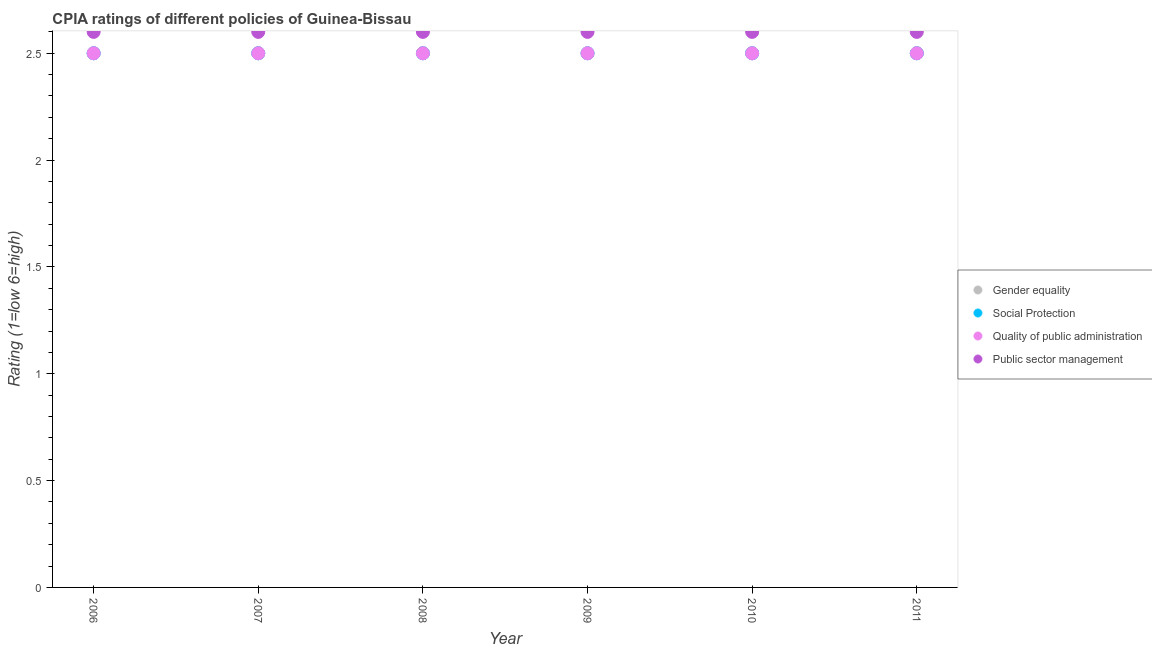Is the number of dotlines equal to the number of legend labels?
Make the answer very short. Yes. Across all years, what is the minimum cpia rating of public sector management?
Keep it short and to the point. 2.6. In which year was the cpia rating of gender equality maximum?
Your answer should be compact. 2006. What is the total cpia rating of social protection in the graph?
Provide a succinct answer. 15. What is the difference between the cpia rating of gender equality in 2011 and the cpia rating of public sector management in 2010?
Offer a very short reply. -0.1. In the year 2010, what is the difference between the cpia rating of quality of public administration and cpia rating of public sector management?
Offer a terse response. -0.1. In how many years, is the cpia rating of quality of public administration greater than 1.4?
Make the answer very short. 6. What is the ratio of the cpia rating of public sector management in 2006 to that in 2008?
Give a very brief answer. 1. Is the cpia rating of quality of public administration in 2009 less than that in 2011?
Your answer should be compact. No. Is the difference between the cpia rating of quality of public administration in 2007 and 2010 greater than the difference between the cpia rating of gender equality in 2007 and 2010?
Offer a very short reply. No. What is the difference between the highest and the lowest cpia rating of social protection?
Provide a short and direct response. 0. In how many years, is the cpia rating of public sector management greater than the average cpia rating of public sector management taken over all years?
Provide a succinct answer. 0. Is it the case that in every year, the sum of the cpia rating of public sector management and cpia rating of gender equality is greater than the sum of cpia rating of quality of public administration and cpia rating of social protection?
Provide a succinct answer. Yes. Is it the case that in every year, the sum of the cpia rating of gender equality and cpia rating of social protection is greater than the cpia rating of quality of public administration?
Keep it short and to the point. Yes. Is the cpia rating of social protection strictly less than the cpia rating of quality of public administration over the years?
Give a very brief answer. No. What is the difference between two consecutive major ticks on the Y-axis?
Make the answer very short. 0.5. Does the graph contain any zero values?
Ensure brevity in your answer.  No. Does the graph contain grids?
Provide a succinct answer. No. How many legend labels are there?
Make the answer very short. 4. What is the title of the graph?
Keep it short and to the point. CPIA ratings of different policies of Guinea-Bissau. Does "Minerals" appear as one of the legend labels in the graph?
Provide a short and direct response. No. What is the label or title of the X-axis?
Your response must be concise. Year. What is the label or title of the Y-axis?
Ensure brevity in your answer.  Rating (1=low 6=high). What is the Rating (1=low 6=high) in Social Protection in 2006?
Your answer should be very brief. 2.5. What is the Rating (1=low 6=high) in Public sector management in 2006?
Your answer should be compact. 2.6. What is the Rating (1=low 6=high) of Quality of public administration in 2007?
Give a very brief answer. 2.5. What is the Rating (1=low 6=high) in Gender equality in 2008?
Keep it short and to the point. 2.5. What is the Rating (1=low 6=high) in Social Protection in 2008?
Your response must be concise. 2.5. What is the Rating (1=low 6=high) in Quality of public administration in 2008?
Make the answer very short. 2.5. What is the Rating (1=low 6=high) in Gender equality in 2009?
Keep it short and to the point. 2.5. What is the Rating (1=low 6=high) in Social Protection in 2009?
Offer a terse response. 2.5. What is the Rating (1=low 6=high) in Gender equality in 2010?
Make the answer very short. 2.5. What is the Rating (1=low 6=high) of Social Protection in 2010?
Keep it short and to the point. 2.5. What is the Rating (1=low 6=high) in Public sector management in 2010?
Offer a very short reply. 2.6. What is the Rating (1=low 6=high) in Gender equality in 2011?
Your response must be concise. 2.5. What is the Rating (1=low 6=high) in Social Protection in 2011?
Offer a very short reply. 2.5. Across all years, what is the maximum Rating (1=low 6=high) of Gender equality?
Make the answer very short. 2.5. Across all years, what is the maximum Rating (1=low 6=high) of Quality of public administration?
Offer a very short reply. 2.5. Across all years, what is the minimum Rating (1=low 6=high) in Gender equality?
Offer a terse response. 2.5. Across all years, what is the minimum Rating (1=low 6=high) in Public sector management?
Your answer should be very brief. 2.6. What is the total Rating (1=low 6=high) of Gender equality in the graph?
Ensure brevity in your answer.  15. What is the total Rating (1=low 6=high) in Quality of public administration in the graph?
Offer a very short reply. 15. What is the difference between the Rating (1=low 6=high) of Quality of public administration in 2006 and that in 2007?
Your answer should be very brief. 0. What is the difference between the Rating (1=low 6=high) of Quality of public administration in 2006 and that in 2008?
Make the answer very short. 0. What is the difference between the Rating (1=low 6=high) in Public sector management in 2006 and that in 2008?
Offer a very short reply. 0. What is the difference between the Rating (1=low 6=high) in Social Protection in 2006 and that in 2009?
Ensure brevity in your answer.  0. What is the difference between the Rating (1=low 6=high) in Public sector management in 2006 and that in 2009?
Provide a short and direct response. 0. What is the difference between the Rating (1=low 6=high) in Social Protection in 2006 and that in 2010?
Provide a short and direct response. 0. What is the difference between the Rating (1=low 6=high) in Quality of public administration in 2006 and that in 2010?
Provide a succinct answer. 0. What is the difference between the Rating (1=low 6=high) of Public sector management in 2006 and that in 2010?
Your answer should be very brief. 0. What is the difference between the Rating (1=low 6=high) in Gender equality in 2006 and that in 2011?
Make the answer very short. 0. What is the difference between the Rating (1=low 6=high) of Social Protection in 2006 and that in 2011?
Keep it short and to the point. 0. What is the difference between the Rating (1=low 6=high) of Quality of public administration in 2006 and that in 2011?
Your answer should be very brief. 0. What is the difference between the Rating (1=low 6=high) of Social Protection in 2007 and that in 2008?
Offer a very short reply. 0. What is the difference between the Rating (1=low 6=high) in Public sector management in 2007 and that in 2008?
Provide a succinct answer. 0. What is the difference between the Rating (1=low 6=high) in Social Protection in 2007 and that in 2009?
Your response must be concise. 0. What is the difference between the Rating (1=low 6=high) of Quality of public administration in 2007 and that in 2009?
Your answer should be compact. 0. What is the difference between the Rating (1=low 6=high) of Public sector management in 2007 and that in 2009?
Give a very brief answer. 0. What is the difference between the Rating (1=low 6=high) in Gender equality in 2007 and that in 2010?
Your answer should be very brief. 0. What is the difference between the Rating (1=low 6=high) in Quality of public administration in 2007 and that in 2010?
Provide a succinct answer. 0. What is the difference between the Rating (1=low 6=high) of Gender equality in 2007 and that in 2011?
Offer a terse response. 0. What is the difference between the Rating (1=low 6=high) in Social Protection in 2007 and that in 2011?
Keep it short and to the point. 0. What is the difference between the Rating (1=low 6=high) in Quality of public administration in 2007 and that in 2011?
Ensure brevity in your answer.  0. What is the difference between the Rating (1=low 6=high) of Gender equality in 2008 and that in 2010?
Your response must be concise. 0. What is the difference between the Rating (1=low 6=high) in Quality of public administration in 2008 and that in 2010?
Offer a terse response. 0. What is the difference between the Rating (1=low 6=high) in Public sector management in 2008 and that in 2010?
Provide a succinct answer. 0. What is the difference between the Rating (1=low 6=high) in Quality of public administration in 2008 and that in 2011?
Give a very brief answer. 0. What is the difference between the Rating (1=low 6=high) of Gender equality in 2009 and that in 2010?
Your answer should be compact. 0. What is the difference between the Rating (1=low 6=high) of Social Protection in 2009 and that in 2010?
Your response must be concise. 0. What is the difference between the Rating (1=low 6=high) in Public sector management in 2009 and that in 2010?
Give a very brief answer. 0. What is the difference between the Rating (1=low 6=high) of Social Protection in 2009 and that in 2011?
Make the answer very short. 0. What is the difference between the Rating (1=low 6=high) in Quality of public administration in 2009 and that in 2011?
Your response must be concise. 0. What is the difference between the Rating (1=low 6=high) of Public sector management in 2009 and that in 2011?
Provide a short and direct response. 0. What is the difference between the Rating (1=low 6=high) in Gender equality in 2010 and that in 2011?
Provide a succinct answer. 0. What is the difference between the Rating (1=low 6=high) of Social Protection in 2010 and that in 2011?
Provide a short and direct response. 0. What is the difference between the Rating (1=low 6=high) in Quality of public administration in 2010 and that in 2011?
Your answer should be very brief. 0. What is the difference between the Rating (1=low 6=high) in Gender equality in 2006 and the Rating (1=low 6=high) in Social Protection in 2008?
Make the answer very short. 0. What is the difference between the Rating (1=low 6=high) of Gender equality in 2006 and the Rating (1=low 6=high) of Quality of public administration in 2008?
Your answer should be compact. 0. What is the difference between the Rating (1=low 6=high) in Gender equality in 2006 and the Rating (1=low 6=high) in Social Protection in 2009?
Keep it short and to the point. 0. What is the difference between the Rating (1=low 6=high) in Gender equality in 2006 and the Rating (1=low 6=high) in Quality of public administration in 2009?
Your answer should be very brief. 0. What is the difference between the Rating (1=low 6=high) in Gender equality in 2006 and the Rating (1=low 6=high) in Public sector management in 2009?
Provide a short and direct response. -0.1. What is the difference between the Rating (1=low 6=high) of Social Protection in 2006 and the Rating (1=low 6=high) of Public sector management in 2009?
Your answer should be very brief. -0.1. What is the difference between the Rating (1=low 6=high) of Gender equality in 2006 and the Rating (1=low 6=high) of Social Protection in 2010?
Make the answer very short. 0. What is the difference between the Rating (1=low 6=high) in Social Protection in 2006 and the Rating (1=low 6=high) in Quality of public administration in 2010?
Your answer should be compact. 0. What is the difference between the Rating (1=low 6=high) in Social Protection in 2006 and the Rating (1=low 6=high) in Public sector management in 2010?
Keep it short and to the point. -0.1. What is the difference between the Rating (1=low 6=high) of Gender equality in 2006 and the Rating (1=low 6=high) of Social Protection in 2011?
Provide a short and direct response. 0. What is the difference between the Rating (1=low 6=high) of Social Protection in 2006 and the Rating (1=low 6=high) of Quality of public administration in 2011?
Provide a short and direct response. 0. What is the difference between the Rating (1=low 6=high) in Social Protection in 2006 and the Rating (1=low 6=high) in Public sector management in 2011?
Provide a succinct answer. -0.1. What is the difference between the Rating (1=low 6=high) in Quality of public administration in 2006 and the Rating (1=low 6=high) in Public sector management in 2011?
Give a very brief answer. -0.1. What is the difference between the Rating (1=low 6=high) of Gender equality in 2007 and the Rating (1=low 6=high) of Social Protection in 2008?
Your answer should be very brief. 0. What is the difference between the Rating (1=low 6=high) of Gender equality in 2007 and the Rating (1=low 6=high) of Quality of public administration in 2008?
Your answer should be very brief. 0. What is the difference between the Rating (1=low 6=high) of Social Protection in 2007 and the Rating (1=low 6=high) of Public sector management in 2008?
Provide a succinct answer. -0.1. What is the difference between the Rating (1=low 6=high) in Gender equality in 2007 and the Rating (1=low 6=high) in Social Protection in 2009?
Offer a very short reply. 0. What is the difference between the Rating (1=low 6=high) in Gender equality in 2007 and the Rating (1=low 6=high) in Public sector management in 2009?
Provide a short and direct response. -0.1. What is the difference between the Rating (1=low 6=high) in Gender equality in 2007 and the Rating (1=low 6=high) in Social Protection in 2010?
Give a very brief answer. 0. What is the difference between the Rating (1=low 6=high) in Gender equality in 2007 and the Rating (1=low 6=high) in Quality of public administration in 2010?
Offer a terse response. 0. What is the difference between the Rating (1=low 6=high) in Social Protection in 2007 and the Rating (1=low 6=high) in Public sector management in 2010?
Your response must be concise. -0.1. What is the difference between the Rating (1=low 6=high) of Quality of public administration in 2007 and the Rating (1=low 6=high) of Public sector management in 2010?
Provide a short and direct response. -0.1. What is the difference between the Rating (1=low 6=high) of Gender equality in 2007 and the Rating (1=low 6=high) of Quality of public administration in 2011?
Provide a succinct answer. 0. What is the difference between the Rating (1=low 6=high) in Gender equality in 2007 and the Rating (1=low 6=high) in Public sector management in 2011?
Your answer should be very brief. -0.1. What is the difference between the Rating (1=low 6=high) of Social Protection in 2007 and the Rating (1=low 6=high) of Quality of public administration in 2011?
Give a very brief answer. 0. What is the difference between the Rating (1=low 6=high) of Social Protection in 2007 and the Rating (1=low 6=high) of Public sector management in 2011?
Ensure brevity in your answer.  -0.1. What is the difference between the Rating (1=low 6=high) in Quality of public administration in 2007 and the Rating (1=low 6=high) in Public sector management in 2011?
Your answer should be very brief. -0.1. What is the difference between the Rating (1=low 6=high) in Gender equality in 2008 and the Rating (1=low 6=high) in Public sector management in 2009?
Give a very brief answer. -0.1. What is the difference between the Rating (1=low 6=high) in Social Protection in 2008 and the Rating (1=low 6=high) in Quality of public administration in 2009?
Your response must be concise. 0. What is the difference between the Rating (1=low 6=high) in Quality of public administration in 2008 and the Rating (1=low 6=high) in Public sector management in 2009?
Offer a terse response. -0.1. What is the difference between the Rating (1=low 6=high) of Gender equality in 2008 and the Rating (1=low 6=high) of Social Protection in 2010?
Make the answer very short. 0. What is the difference between the Rating (1=low 6=high) in Social Protection in 2008 and the Rating (1=low 6=high) in Quality of public administration in 2010?
Offer a terse response. 0. What is the difference between the Rating (1=low 6=high) in Social Protection in 2008 and the Rating (1=low 6=high) in Public sector management in 2010?
Your answer should be very brief. -0.1. What is the difference between the Rating (1=low 6=high) in Quality of public administration in 2008 and the Rating (1=low 6=high) in Public sector management in 2010?
Make the answer very short. -0.1. What is the difference between the Rating (1=low 6=high) in Gender equality in 2008 and the Rating (1=low 6=high) in Quality of public administration in 2011?
Your answer should be compact. 0. What is the difference between the Rating (1=low 6=high) in Social Protection in 2008 and the Rating (1=low 6=high) in Quality of public administration in 2011?
Your answer should be very brief. 0. What is the difference between the Rating (1=low 6=high) of Quality of public administration in 2008 and the Rating (1=low 6=high) of Public sector management in 2011?
Offer a terse response. -0.1. What is the difference between the Rating (1=low 6=high) of Gender equality in 2009 and the Rating (1=low 6=high) of Quality of public administration in 2010?
Offer a very short reply. 0. What is the difference between the Rating (1=low 6=high) in Gender equality in 2009 and the Rating (1=low 6=high) in Public sector management in 2010?
Offer a very short reply. -0.1. What is the difference between the Rating (1=low 6=high) of Social Protection in 2009 and the Rating (1=low 6=high) of Public sector management in 2010?
Offer a terse response. -0.1. What is the difference between the Rating (1=low 6=high) in Gender equality in 2009 and the Rating (1=low 6=high) in Social Protection in 2011?
Ensure brevity in your answer.  0. What is the difference between the Rating (1=low 6=high) of Gender equality in 2009 and the Rating (1=low 6=high) of Public sector management in 2011?
Ensure brevity in your answer.  -0.1. What is the difference between the Rating (1=low 6=high) of Social Protection in 2009 and the Rating (1=low 6=high) of Public sector management in 2011?
Keep it short and to the point. -0.1. What is the difference between the Rating (1=low 6=high) in Gender equality in 2010 and the Rating (1=low 6=high) in Social Protection in 2011?
Ensure brevity in your answer.  0. What is the difference between the Rating (1=low 6=high) of Gender equality in 2010 and the Rating (1=low 6=high) of Public sector management in 2011?
Ensure brevity in your answer.  -0.1. What is the difference between the Rating (1=low 6=high) in Quality of public administration in 2010 and the Rating (1=low 6=high) in Public sector management in 2011?
Offer a very short reply. -0.1. What is the average Rating (1=low 6=high) of Gender equality per year?
Ensure brevity in your answer.  2.5. What is the average Rating (1=low 6=high) of Social Protection per year?
Make the answer very short. 2.5. What is the average Rating (1=low 6=high) of Quality of public administration per year?
Offer a terse response. 2.5. In the year 2007, what is the difference between the Rating (1=low 6=high) in Gender equality and Rating (1=low 6=high) in Quality of public administration?
Make the answer very short. 0. In the year 2007, what is the difference between the Rating (1=low 6=high) in Gender equality and Rating (1=low 6=high) in Public sector management?
Keep it short and to the point. -0.1. In the year 2007, what is the difference between the Rating (1=low 6=high) of Social Protection and Rating (1=low 6=high) of Quality of public administration?
Give a very brief answer. 0. In the year 2007, what is the difference between the Rating (1=low 6=high) of Social Protection and Rating (1=low 6=high) of Public sector management?
Ensure brevity in your answer.  -0.1. In the year 2007, what is the difference between the Rating (1=low 6=high) in Quality of public administration and Rating (1=low 6=high) in Public sector management?
Your response must be concise. -0.1. In the year 2008, what is the difference between the Rating (1=low 6=high) in Gender equality and Rating (1=low 6=high) in Quality of public administration?
Your answer should be very brief. 0. In the year 2008, what is the difference between the Rating (1=low 6=high) in Gender equality and Rating (1=low 6=high) in Public sector management?
Make the answer very short. -0.1. In the year 2009, what is the difference between the Rating (1=low 6=high) of Gender equality and Rating (1=low 6=high) of Public sector management?
Your answer should be compact. -0.1. In the year 2009, what is the difference between the Rating (1=low 6=high) in Social Protection and Rating (1=low 6=high) in Public sector management?
Provide a succinct answer. -0.1. In the year 2010, what is the difference between the Rating (1=low 6=high) of Gender equality and Rating (1=low 6=high) of Social Protection?
Give a very brief answer. 0. In the year 2010, what is the difference between the Rating (1=low 6=high) of Gender equality and Rating (1=low 6=high) of Quality of public administration?
Provide a succinct answer. 0. In the year 2010, what is the difference between the Rating (1=low 6=high) in Gender equality and Rating (1=low 6=high) in Public sector management?
Your answer should be very brief. -0.1. In the year 2010, what is the difference between the Rating (1=low 6=high) of Social Protection and Rating (1=low 6=high) of Public sector management?
Offer a terse response. -0.1. In the year 2010, what is the difference between the Rating (1=low 6=high) in Quality of public administration and Rating (1=low 6=high) in Public sector management?
Provide a short and direct response. -0.1. In the year 2011, what is the difference between the Rating (1=low 6=high) in Gender equality and Rating (1=low 6=high) in Public sector management?
Your answer should be compact. -0.1. In the year 2011, what is the difference between the Rating (1=low 6=high) in Social Protection and Rating (1=low 6=high) in Quality of public administration?
Give a very brief answer. 0. In the year 2011, what is the difference between the Rating (1=low 6=high) in Quality of public administration and Rating (1=low 6=high) in Public sector management?
Your answer should be compact. -0.1. What is the ratio of the Rating (1=low 6=high) of Gender equality in 2006 to that in 2007?
Your answer should be very brief. 1. What is the ratio of the Rating (1=low 6=high) in Quality of public administration in 2006 to that in 2007?
Your response must be concise. 1. What is the ratio of the Rating (1=low 6=high) of Public sector management in 2006 to that in 2007?
Give a very brief answer. 1. What is the ratio of the Rating (1=low 6=high) in Quality of public administration in 2006 to that in 2008?
Keep it short and to the point. 1. What is the ratio of the Rating (1=low 6=high) of Gender equality in 2006 to that in 2009?
Provide a succinct answer. 1. What is the ratio of the Rating (1=low 6=high) of Social Protection in 2006 to that in 2009?
Give a very brief answer. 1. What is the ratio of the Rating (1=low 6=high) of Quality of public administration in 2006 to that in 2009?
Provide a short and direct response. 1. What is the ratio of the Rating (1=low 6=high) of Public sector management in 2006 to that in 2009?
Offer a terse response. 1. What is the ratio of the Rating (1=low 6=high) in Social Protection in 2006 to that in 2010?
Provide a short and direct response. 1. What is the ratio of the Rating (1=low 6=high) of Quality of public administration in 2006 to that in 2010?
Ensure brevity in your answer.  1. What is the ratio of the Rating (1=low 6=high) in Gender equality in 2006 to that in 2011?
Keep it short and to the point. 1. What is the ratio of the Rating (1=low 6=high) in Quality of public administration in 2006 to that in 2011?
Your response must be concise. 1. What is the ratio of the Rating (1=low 6=high) in Public sector management in 2006 to that in 2011?
Offer a terse response. 1. What is the ratio of the Rating (1=low 6=high) of Gender equality in 2007 to that in 2008?
Offer a terse response. 1. What is the ratio of the Rating (1=low 6=high) in Social Protection in 2007 to that in 2008?
Offer a terse response. 1. What is the ratio of the Rating (1=low 6=high) in Public sector management in 2007 to that in 2008?
Offer a very short reply. 1. What is the ratio of the Rating (1=low 6=high) in Quality of public administration in 2007 to that in 2009?
Your answer should be very brief. 1. What is the ratio of the Rating (1=low 6=high) of Social Protection in 2007 to that in 2010?
Offer a very short reply. 1. What is the ratio of the Rating (1=low 6=high) in Quality of public administration in 2007 to that in 2010?
Provide a short and direct response. 1. What is the ratio of the Rating (1=low 6=high) of Social Protection in 2007 to that in 2011?
Your answer should be compact. 1. What is the ratio of the Rating (1=low 6=high) in Quality of public administration in 2007 to that in 2011?
Your answer should be very brief. 1. What is the ratio of the Rating (1=low 6=high) in Social Protection in 2008 to that in 2009?
Make the answer very short. 1. What is the ratio of the Rating (1=low 6=high) of Quality of public administration in 2008 to that in 2009?
Give a very brief answer. 1. What is the ratio of the Rating (1=low 6=high) in Social Protection in 2008 to that in 2010?
Ensure brevity in your answer.  1. What is the ratio of the Rating (1=low 6=high) of Public sector management in 2008 to that in 2011?
Make the answer very short. 1. What is the ratio of the Rating (1=low 6=high) of Gender equality in 2009 to that in 2011?
Ensure brevity in your answer.  1. What is the ratio of the Rating (1=low 6=high) of Social Protection in 2009 to that in 2011?
Ensure brevity in your answer.  1. What is the ratio of the Rating (1=low 6=high) in Quality of public administration in 2009 to that in 2011?
Provide a succinct answer. 1. What is the ratio of the Rating (1=low 6=high) of Gender equality in 2010 to that in 2011?
Give a very brief answer. 1. What is the ratio of the Rating (1=low 6=high) in Social Protection in 2010 to that in 2011?
Your response must be concise. 1. What is the difference between the highest and the second highest Rating (1=low 6=high) in Gender equality?
Ensure brevity in your answer.  0. What is the difference between the highest and the second highest Rating (1=low 6=high) in Social Protection?
Provide a succinct answer. 0. What is the difference between the highest and the second highest Rating (1=low 6=high) of Quality of public administration?
Provide a succinct answer. 0. What is the difference between the highest and the second highest Rating (1=low 6=high) of Public sector management?
Provide a succinct answer. 0. What is the difference between the highest and the lowest Rating (1=low 6=high) in Gender equality?
Ensure brevity in your answer.  0. What is the difference between the highest and the lowest Rating (1=low 6=high) in Quality of public administration?
Make the answer very short. 0. What is the difference between the highest and the lowest Rating (1=low 6=high) of Public sector management?
Give a very brief answer. 0. 